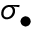Convert formula to latex. <formula><loc_0><loc_0><loc_500><loc_500>\sigma _ { \bullet }</formula> 